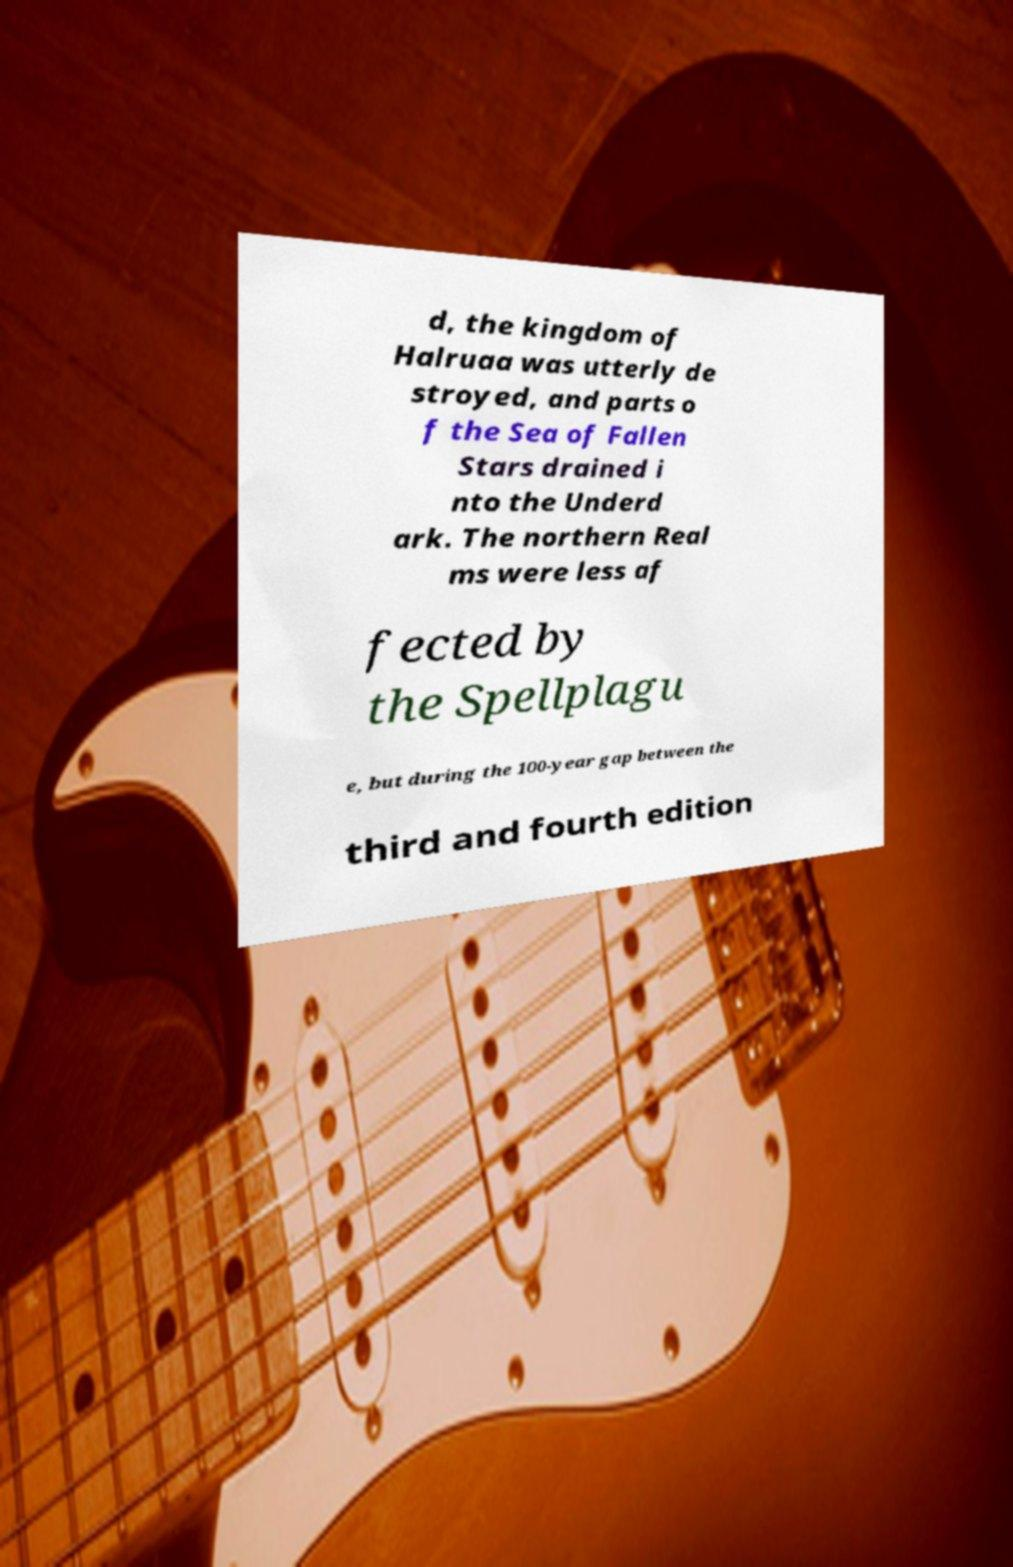I need the written content from this picture converted into text. Can you do that? d, the kingdom of Halruaa was utterly de stroyed, and parts o f the Sea of Fallen Stars drained i nto the Underd ark. The northern Real ms were less af fected by the Spellplagu e, but during the 100-year gap between the third and fourth edition 